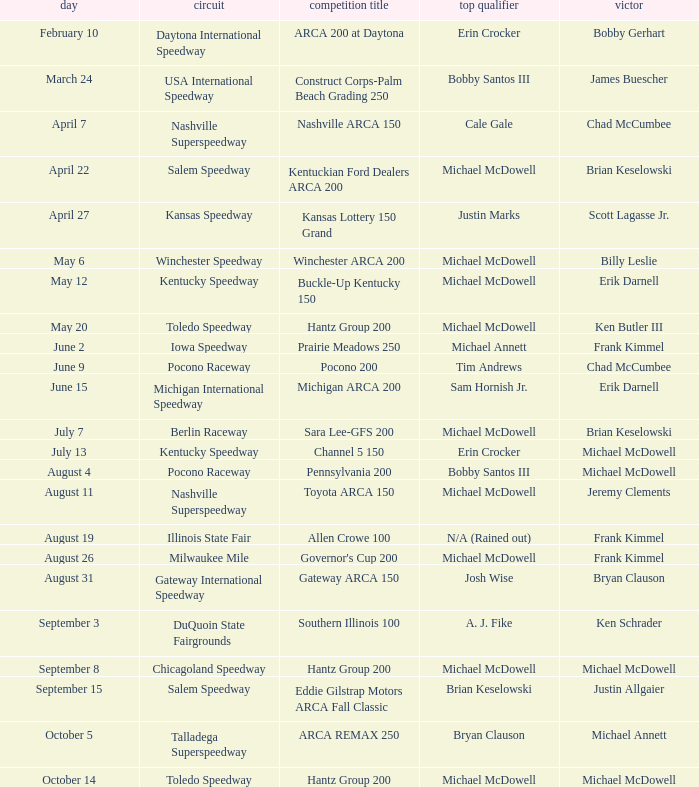Tell me the event name for michael mcdowell and billy leslie Winchester ARCA 200. Could you help me parse every detail presented in this table? {'header': ['day', 'circuit', 'competition title', 'top qualifier', 'victor'], 'rows': [['February 10', 'Daytona International Speedway', 'ARCA 200 at Daytona', 'Erin Crocker', 'Bobby Gerhart'], ['March 24', 'USA International Speedway', 'Construct Corps-Palm Beach Grading 250', 'Bobby Santos III', 'James Buescher'], ['April 7', 'Nashville Superspeedway', 'Nashville ARCA 150', 'Cale Gale', 'Chad McCumbee'], ['April 22', 'Salem Speedway', 'Kentuckian Ford Dealers ARCA 200', 'Michael McDowell', 'Brian Keselowski'], ['April 27', 'Kansas Speedway', 'Kansas Lottery 150 Grand', 'Justin Marks', 'Scott Lagasse Jr.'], ['May 6', 'Winchester Speedway', 'Winchester ARCA 200', 'Michael McDowell', 'Billy Leslie'], ['May 12', 'Kentucky Speedway', 'Buckle-Up Kentucky 150', 'Michael McDowell', 'Erik Darnell'], ['May 20', 'Toledo Speedway', 'Hantz Group 200', 'Michael McDowell', 'Ken Butler III'], ['June 2', 'Iowa Speedway', 'Prairie Meadows 250', 'Michael Annett', 'Frank Kimmel'], ['June 9', 'Pocono Raceway', 'Pocono 200', 'Tim Andrews', 'Chad McCumbee'], ['June 15', 'Michigan International Speedway', 'Michigan ARCA 200', 'Sam Hornish Jr.', 'Erik Darnell'], ['July 7', 'Berlin Raceway', 'Sara Lee-GFS 200', 'Michael McDowell', 'Brian Keselowski'], ['July 13', 'Kentucky Speedway', 'Channel 5 150', 'Erin Crocker', 'Michael McDowell'], ['August 4', 'Pocono Raceway', 'Pennsylvania 200', 'Bobby Santos III', 'Michael McDowell'], ['August 11', 'Nashville Superspeedway', 'Toyota ARCA 150', 'Michael McDowell', 'Jeremy Clements'], ['August 19', 'Illinois State Fair', 'Allen Crowe 100', 'N/A (Rained out)', 'Frank Kimmel'], ['August 26', 'Milwaukee Mile', "Governor's Cup 200", 'Michael McDowell', 'Frank Kimmel'], ['August 31', 'Gateway International Speedway', 'Gateway ARCA 150', 'Josh Wise', 'Bryan Clauson'], ['September 3', 'DuQuoin State Fairgrounds', 'Southern Illinois 100', 'A. J. Fike', 'Ken Schrader'], ['September 8', 'Chicagoland Speedway', 'Hantz Group 200', 'Michael McDowell', 'Michael McDowell'], ['September 15', 'Salem Speedway', 'Eddie Gilstrap Motors ARCA Fall Classic', 'Brian Keselowski', 'Justin Allgaier'], ['October 5', 'Talladega Superspeedway', 'ARCA REMAX 250', 'Bryan Clauson', 'Michael Annett'], ['October 14', 'Toledo Speedway', 'Hantz Group 200', 'Michael McDowell', 'Michael McDowell']]} 